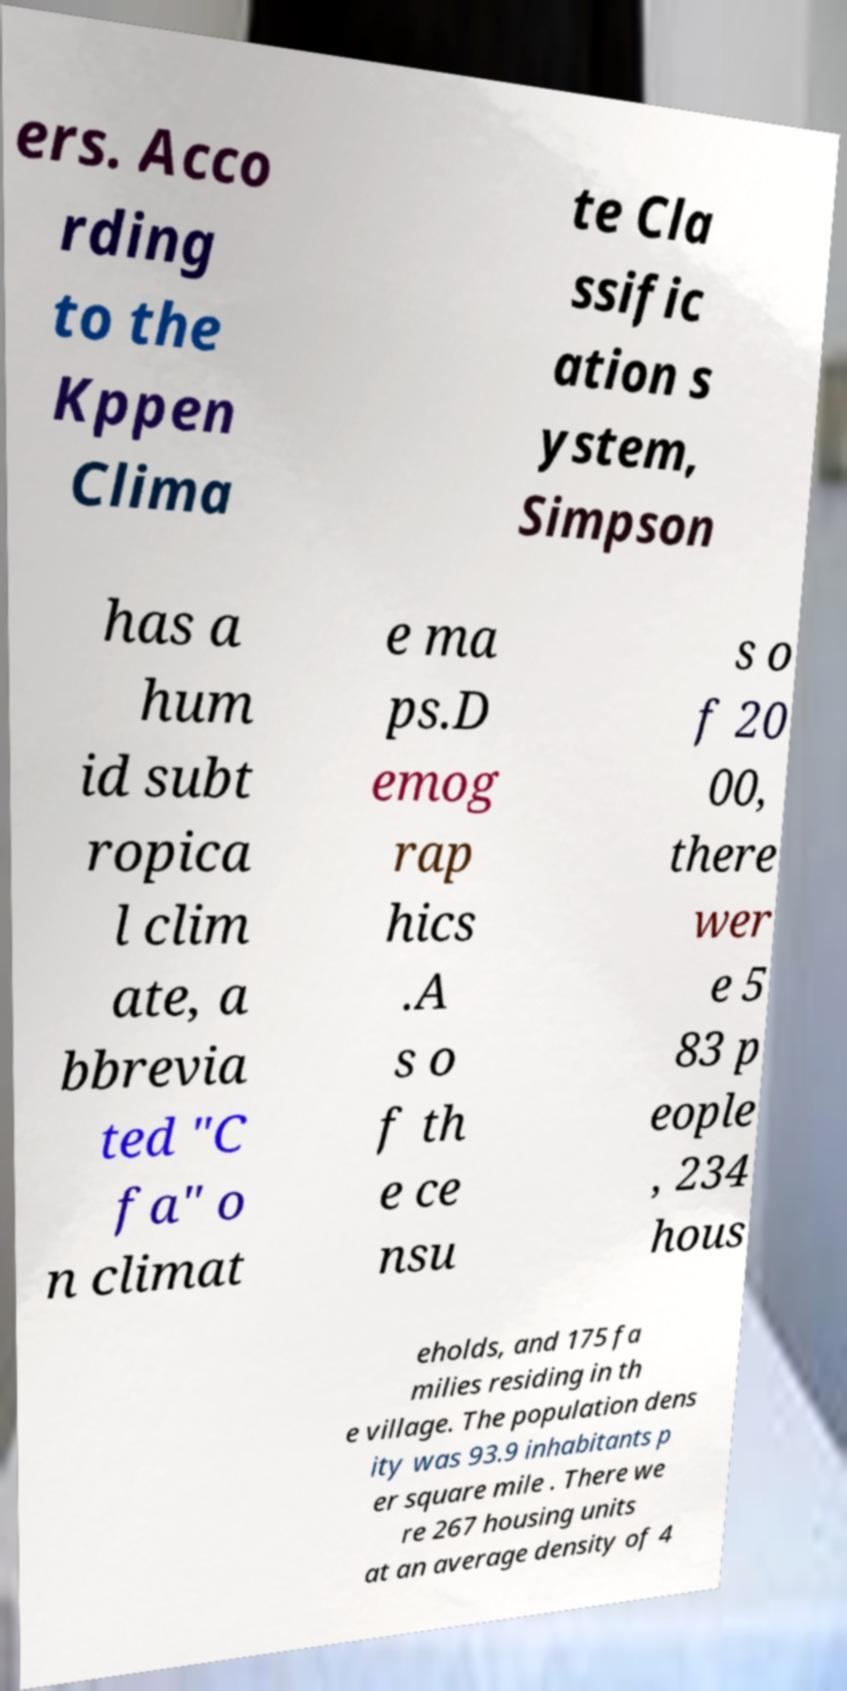For documentation purposes, I need the text within this image transcribed. Could you provide that? ers. Acco rding to the Kppen Clima te Cla ssific ation s ystem, Simpson has a hum id subt ropica l clim ate, a bbrevia ted "C fa" o n climat e ma ps.D emog rap hics .A s o f th e ce nsu s o f 20 00, there wer e 5 83 p eople , 234 hous eholds, and 175 fa milies residing in th e village. The population dens ity was 93.9 inhabitants p er square mile . There we re 267 housing units at an average density of 4 